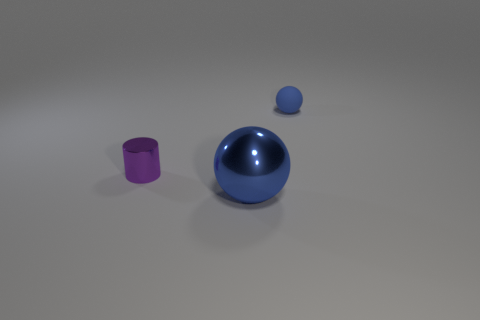What size is the other blue thing that is the same shape as the large metallic thing?
Keep it short and to the point. Small. Are there an equal number of small purple cylinders that are behind the purple cylinder and large blue balls left of the metal sphere?
Your answer should be very brief. Yes. How big is the shiny object that is in front of the purple cylinder?
Your answer should be compact. Large. Is the small metallic thing the same color as the tiny rubber object?
Your answer should be compact. No. Is there any other thing that has the same shape as the purple metal object?
Provide a short and direct response. No. There is a object that is the same color as the matte ball; what is it made of?
Give a very brief answer. Metal. Is the number of large blue balls in front of the purple cylinder the same as the number of metal balls?
Your response must be concise. Yes. Are there any blue metal objects in front of the blue rubber thing?
Offer a very short reply. Yes. There is a purple metal object; is it the same shape as the thing in front of the metallic cylinder?
Give a very brief answer. No. There is a sphere that is the same material as the small cylinder; what is its color?
Offer a very short reply. Blue. 